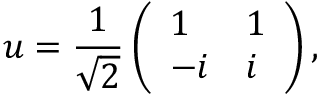Convert formula to latex. <formula><loc_0><loc_0><loc_500><loc_500>u = \frac { 1 } { \sqrt { 2 } } \left ( \begin{array} { l l } { 1 } & { 1 } \\ { - i } & { i } \end{array} \right ) ,</formula> 